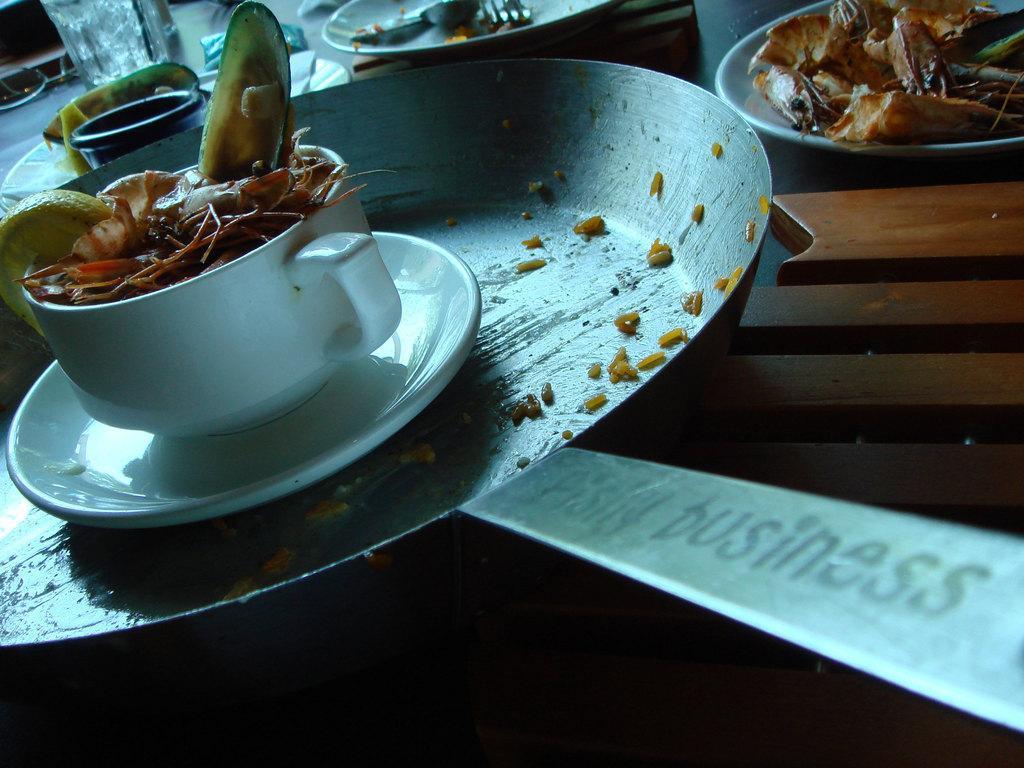Could you give a brief overview of what you see in this image? In this image we can see some food placed on the plate. We can see some food waste in a cup in the image. There are many utensils placed on the table. 